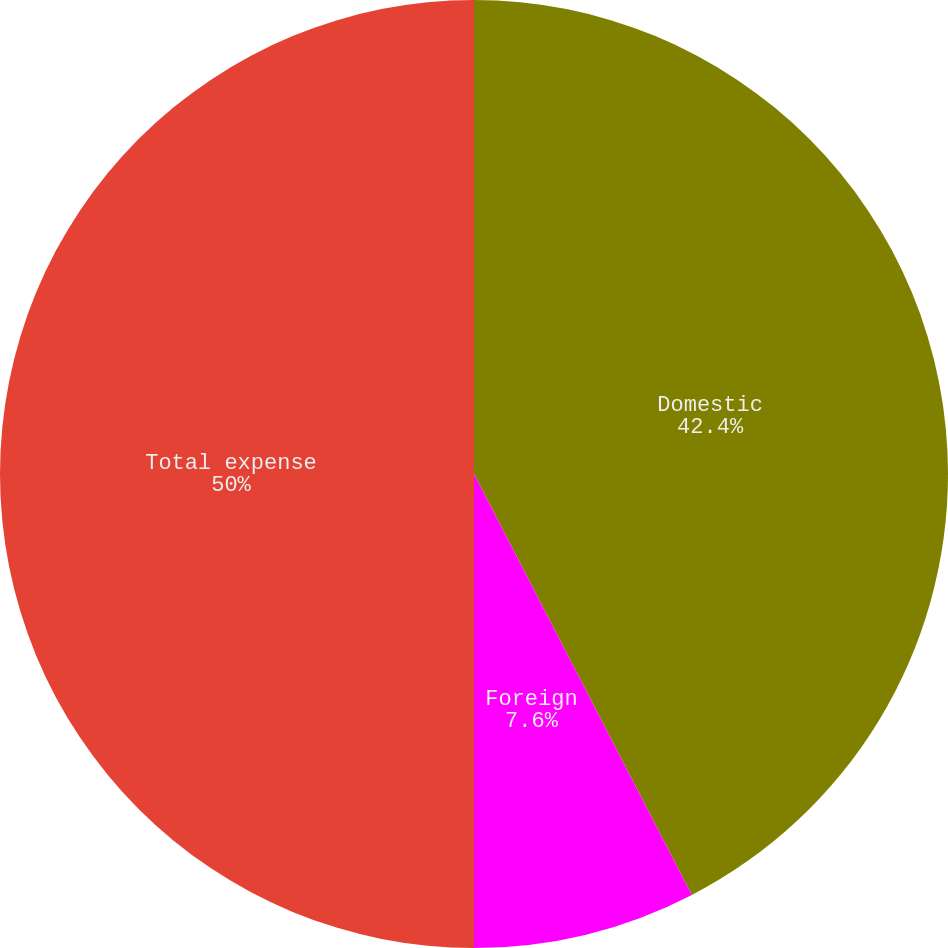<chart> <loc_0><loc_0><loc_500><loc_500><pie_chart><fcel>Domestic<fcel>Foreign<fcel>Total expense<nl><fcel>42.4%<fcel>7.6%<fcel>50.0%<nl></chart> 